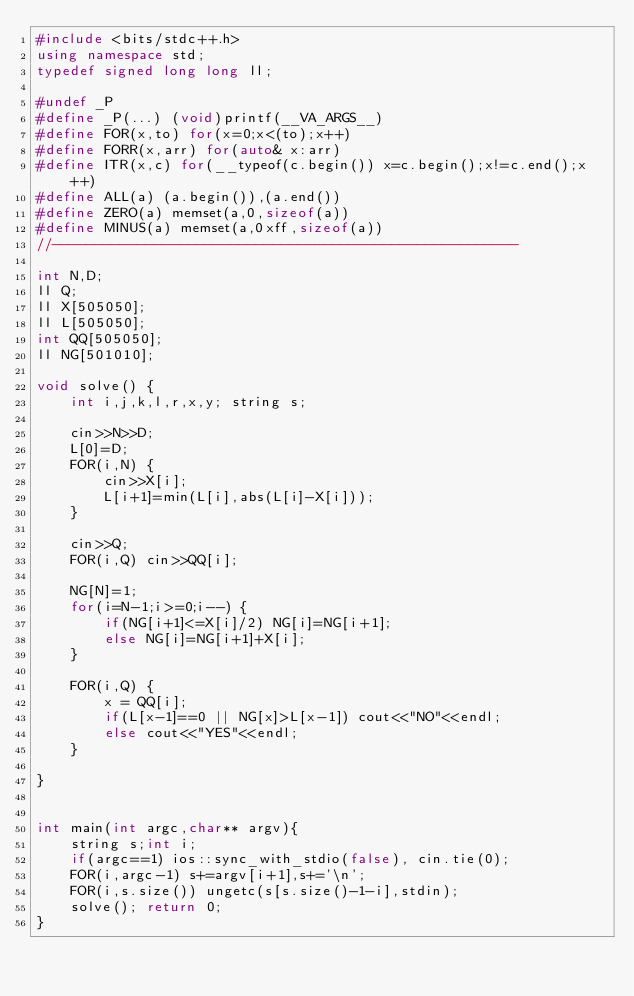<code> <loc_0><loc_0><loc_500><loc_500><_C++_>#include <bits/stdc++.h>
using namespace std;
typedef signed long long ll;

#undef _P
#define _P(...) (void)printf(__VA_ARGS__)
#define FOR(x,to) for(x=0;x<(to);x++)
#define FORR(x,arr) for(auto& x:arr)
#define ITR(x,c) for(__typeof(c.begin()) x=c.begin();x!=c.end();x++)
#define ALL(a) (a.begin()),(a.end())
#define ZERO(a) memset(a,0,sizeof(a))
#define MINUS(a) memset(a,0xff,sizeof(a))
//-------------------------------------------------------

int N,D;
ll Q;
ll X[505050];
ll L[505050];
int QQ[505050];
ll NG[501010];

void solve() {
	int i,j,k,l,r,x,y; string s;
	
	cin>>N>>D;
	L[0]=D;
	FOR(i,N) {
		cin>>X[i];
		L[i+1]=min(L[i],abs(L[i]-X[i]));
	}
	
	cin>>Q;
	FOR(i,Q) cin>>QQ[i];
	
	NG[N]=1;
	for(i=N-1;i>=0;i--) {
		if(NG[i+1]<=X[i]/2) NG[i]=NG[i+1];
		else NG[i]=NG[i+1]+X[i];
	}
	
	FOR(i,Q) {
		x = QQ[i];
		if(L[x-1]==0 || NG[x]>L[x-1]) cout<<"NO"<<endl;
		else cout<<"YES"<<endl;
	}
	
}


int main(int argc,char** argv){
	string s;int i;
	if(argc==1) ios::sync_with_stdio(false), cin.tie(0);
	FOR(i,argc-1) s+=argv[i+1],s+='\n';
	FOR(i,s.size()) ungetc(s[s.size()-1-i],stdin);
	solve(); return 0;
}
</code> 